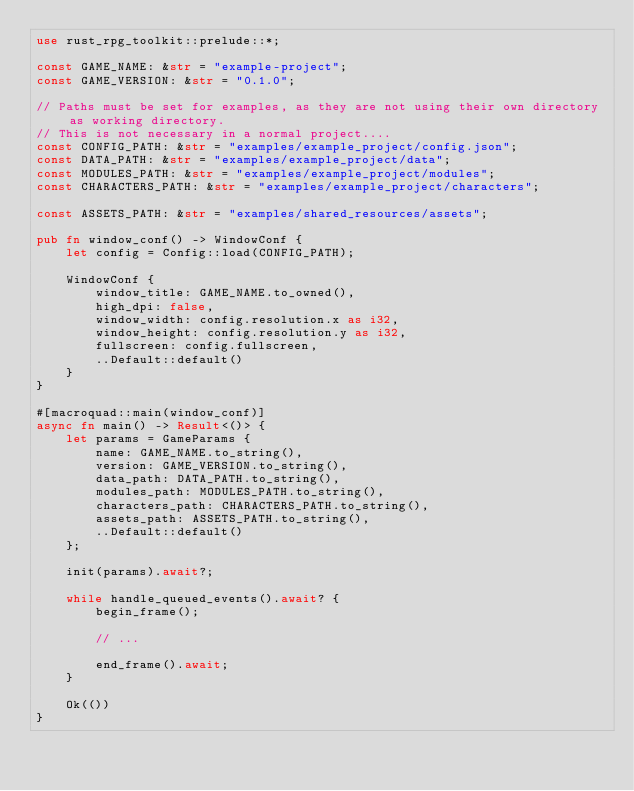Convert code to text. <code><loc_0><loc_0><loc_500><loc_500><_Rust_>use rust_rpg_toolkit::prelude::*;

const GAME_NAME: &str = "example-project";
const GAME_VERSION: &str = "0.1.0";

// Paths must be set for examples, as they are not using their own directory as working directory.
// This is not necessary in a normal project....
const CONFIG_PATH: &str = "examples/example_project/config.json";
const DATA_PATH: &str = "examples/example_project/data";
const MODULES_PATH: &str = "examples/example_project/modules";
const CHARACTERS_PATH: &str = "examples/example_project/characters";

const ASSETS_PATH: &str = "examples/shared_resources/assets";

pub fn window_conf() -> WindowConf {
    let config = Config::load(CONFIG_PATH);

    WindowConf {
        window_title: GAME_NAME.to_owned(),
        high_dpi: false,
        window_width: config.resolution.x as i32,
        window_height: config.resolution.y as i32,
        fullscreen: config.fullscreen,
        ..Default::default()
    }
}

#[macroquad::main(window_conf)]
async fn main() -> Result<()> {
    let params = GameParams {
        name: GAME_NAME.to_string(),
        version: GAME_VERSION.to_string(),
        data_path: DATA_PATH.to_string(),
        modules_path: MODULES_PATH.to_string(),
        characters_path: CHARACTERS_PATH.to_string(),
        assets_path: ASSETS_PATH.to_string(),
        ..Default::default()
    };

    init(params).await?;

    while handle_queued_events().await? {
        begin_frame();

        // ...

        end_frame().await;
    }

    Ok(())
}
</code> 